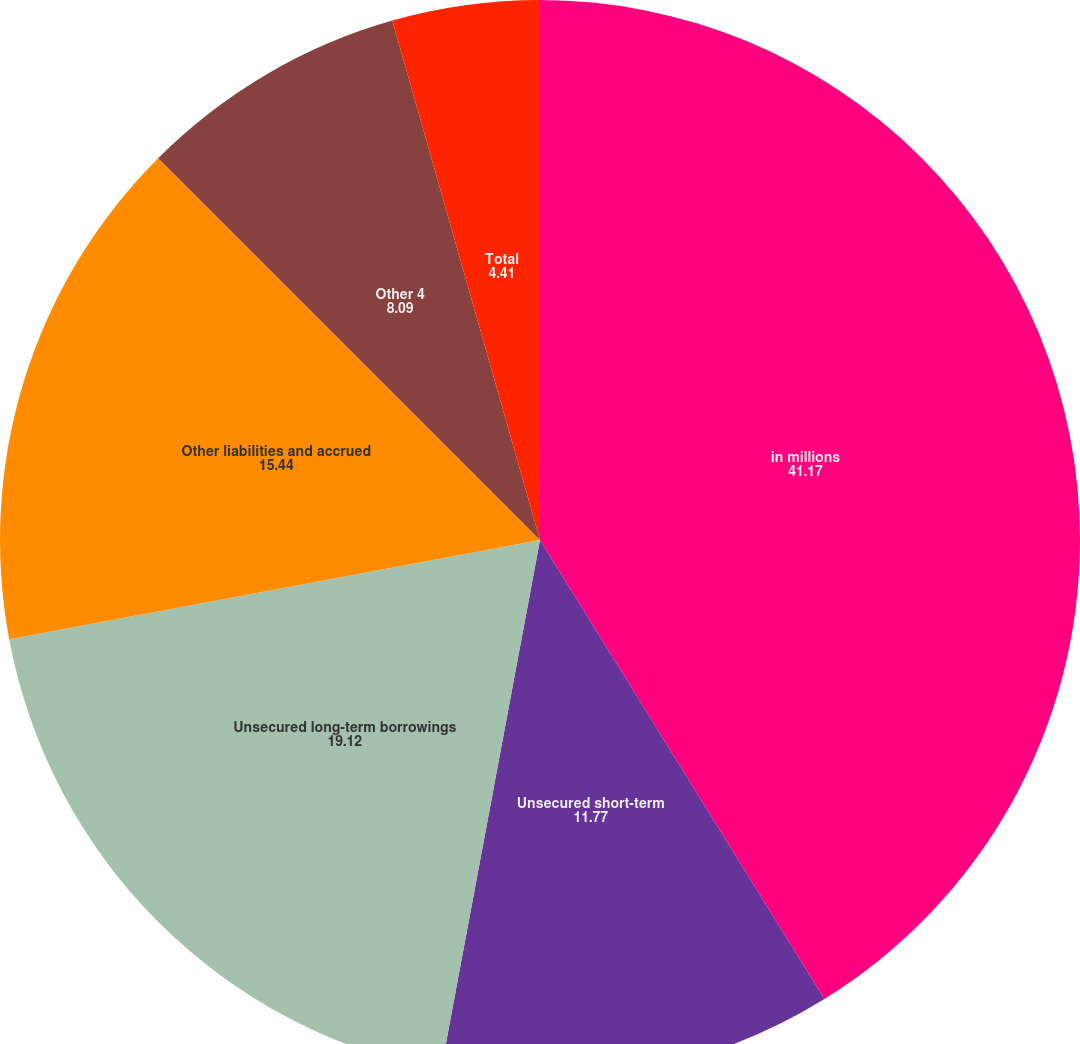<chart> <loc_0><loc_0><loc_500><loc_500><pie_chart><fcel>in millions<fcel>Unsecured short-term<fcel>Unsecured long-term borrowings<fcel>Other liabilities and accrued<fcel>Other 4<fcel>Total<nl><fcel>41.17%<fcel>11.77%<fcel>19.12%<fcel>15.44%<fcel>8.09%<fcel>4.41%<nl></chart> 